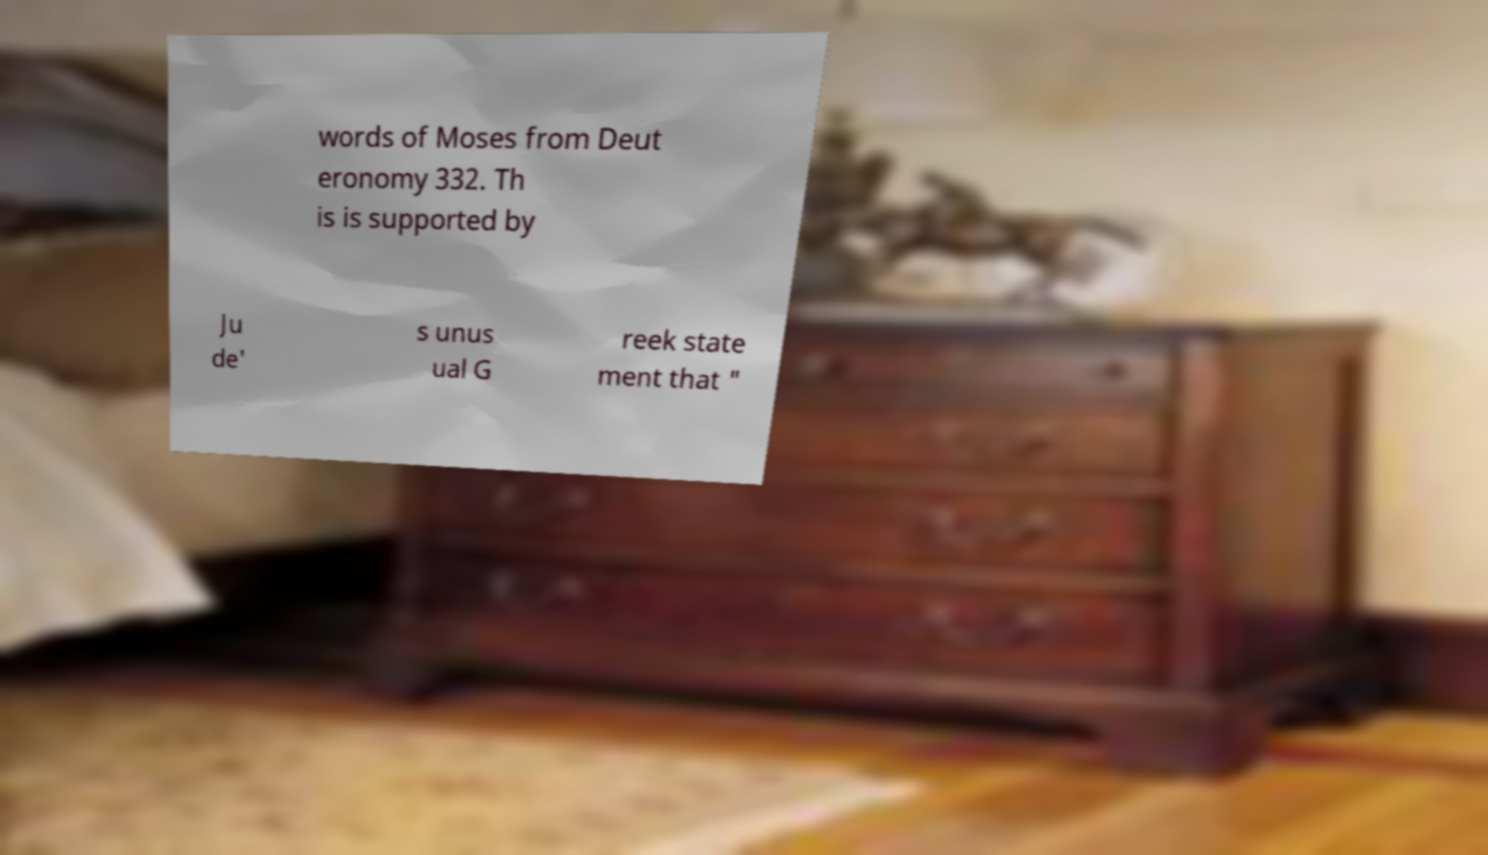Can you accurately transcribe the text from the provided image for me? words of Moses from Deut eronomy 332. Th is is supported by Ju de' s unus ual G reek state ment that " 